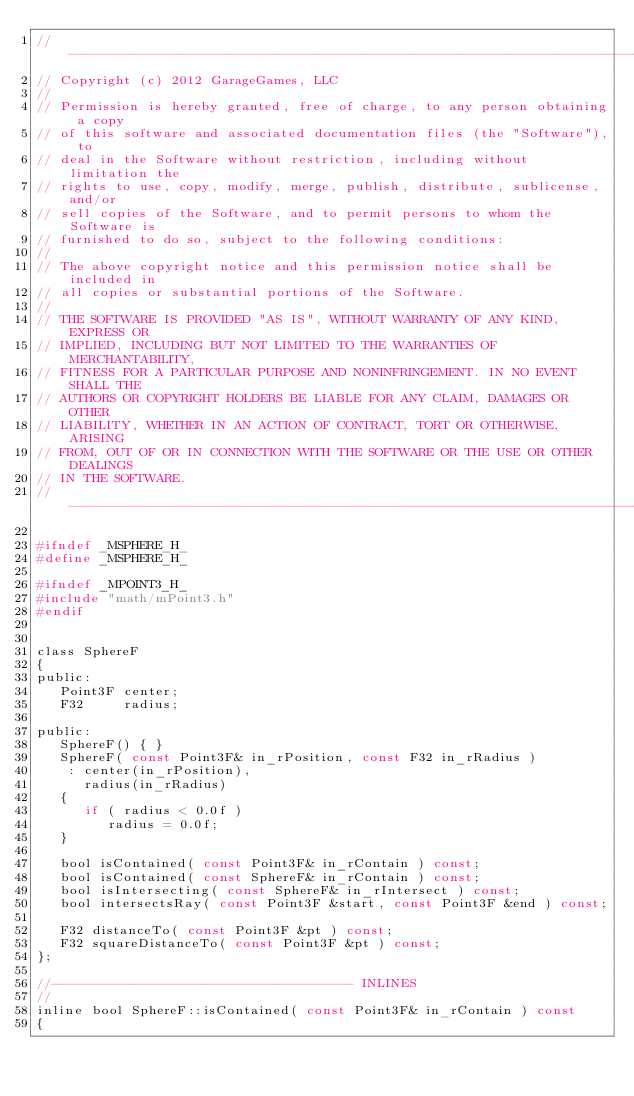Convert code to text. <code><loc_0><loc_0><loc_500><loc_500><_C_>//-----------------------------------------------------------------------------
// Copyright (c) 2012 GarageGames, LLC
//
// Permission is hereby granted, free of charge, to any person obtaining a copy
// of this software and associated documentation files (the "Software"), to
// deal in the Software without restriction, including without limitation the
// rights to use, copy, modify, merge, publish, distribute, sublicense, and/or
// sell copies of the Software, and to permit persons to whom the Software is
// furnished to do so, subject to the following conditions:
//
// The above copyright notice and this permission notice shall be included in
// all copies or substantial portions of the Software.
//
// THE SOFTWARE IS PROVIDED "AS IS", WITHOUT WARRANTY OF ANY KIND, EXPRESS OR
// IMPLIED, INCLUDING BUT NOT LIMITED TO THE WARRANTIES OF MERCHANTABILITY,
// FITNESS FOR A PARTICULAR PURPOSE AND NONINFRINGEMENT. IN NO EVENT SHALL THE
// AUTHORS OR COPYRIGHT HOLDERS BE LIABLE FOR ANY CLAIM, DAMAGES OR OTHER
// LIABILITY, WHETHER IN AN ACTION OF CONTRACT, TORT OR OTHERWISE, ARISING
// FROM, OUT OF OR IN CONNECTION WITH THE SOFTWARE OR THE USE OR OTHER DEALINGS
// IN THE SOFTWARE.
//-----------------------------------------------------------------------------

#ifndef _MSPHERE_H_
#define _MSPHERE_H_

#ifndef _MPOINT3_H_
#include "math/mPoint3.h"
#endif


class SphereF
{
public:
   Point3F center;
   F32     radius;

public:
   SphereF() { }
   SphereF( const Point3F& in_rPosition, const F32 in_rRadius )
    : center(in_rPosition),
      radius(in_rRadius)
   {
      if ( radius < 0.0f )
         radius = 0.0f;
   }

   bool isContained( const Point3F& in_rContain ) const;
   bool isContained( const SphereF& in_rContain ) const;
   bool isIntersecting( const SphereF& in_rIntersect ) const;
   bool intersectsRay( const Point3F &start, const Point3F &end ) const;

   F32 distanceTo( const Point3F &pt ) const;
   F32 squareDistanceTo( const Point3F &pt ) const;
};

//-------------------------------------- INLINES
//
inline bool SphereF::isContained( const Point3F& in_rContain ) const
{</code> 